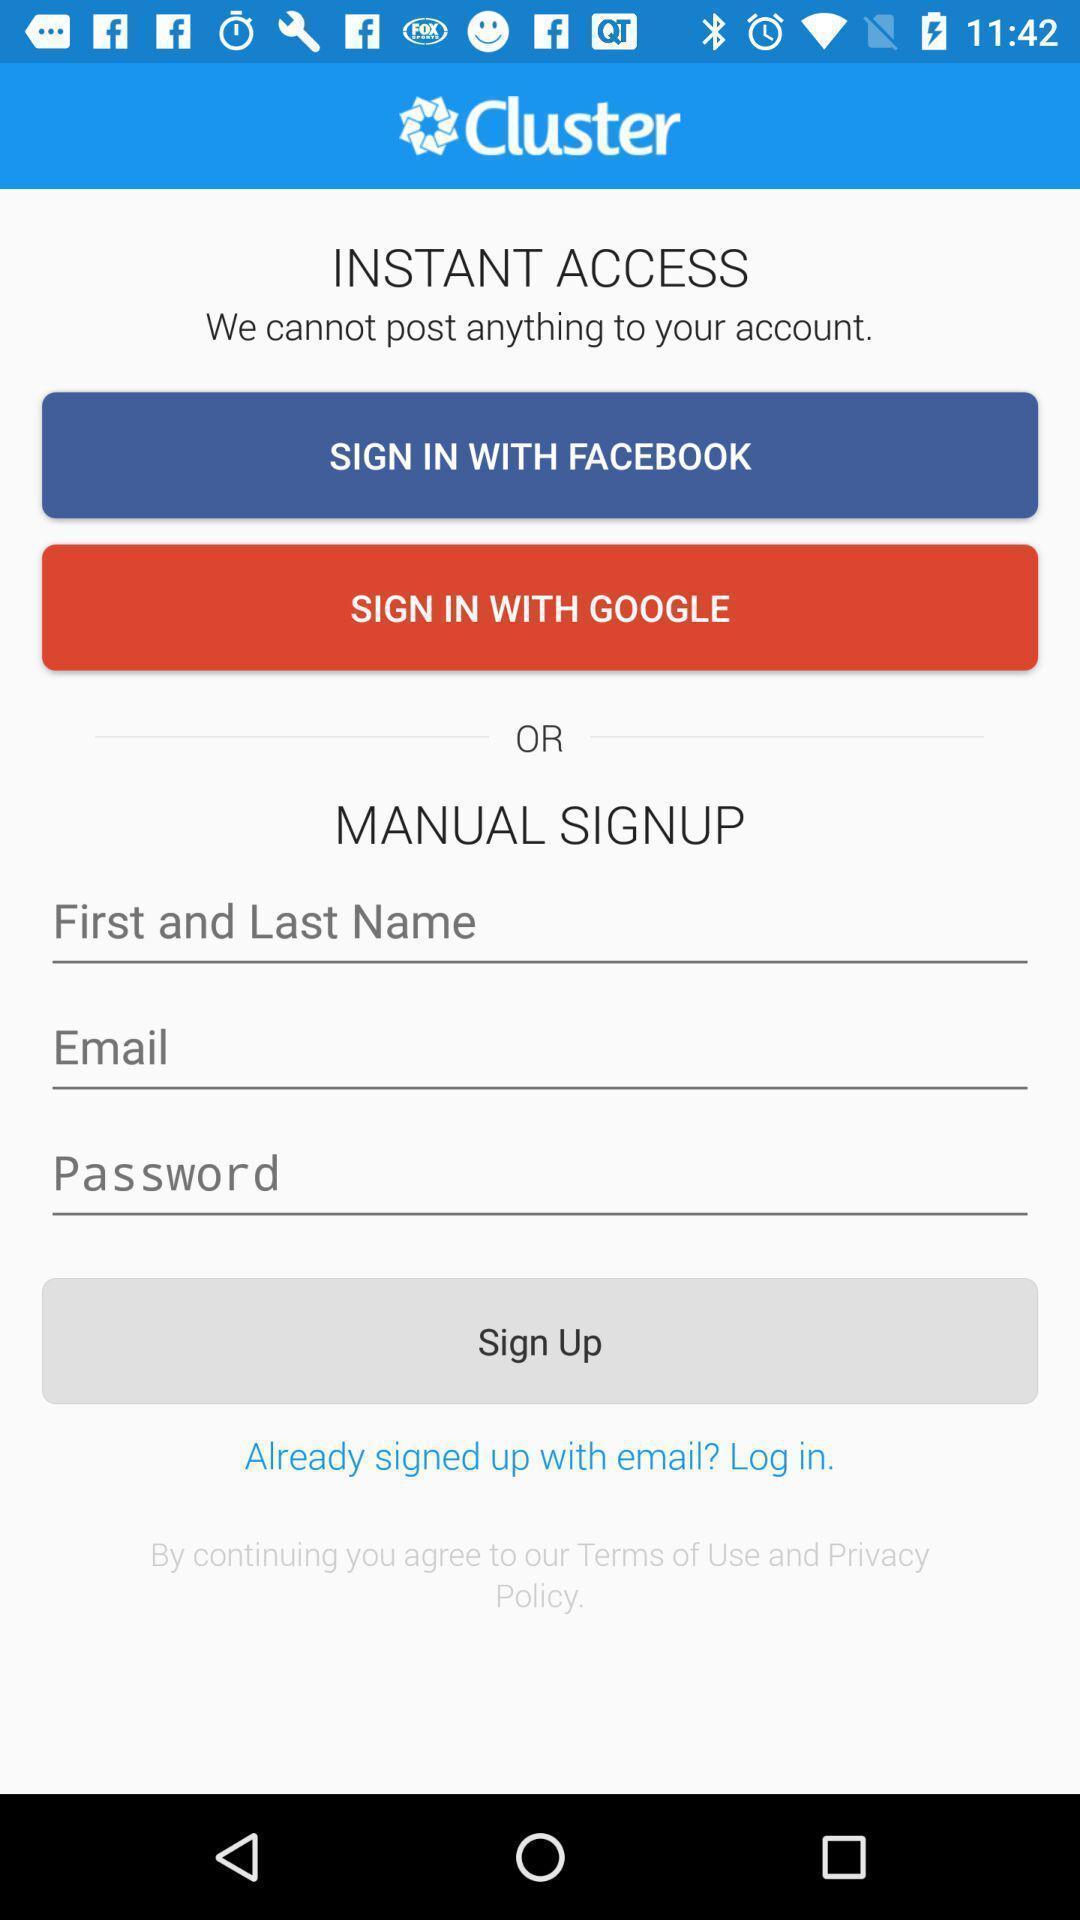Provide a description of this screenshot. Sign up page. 